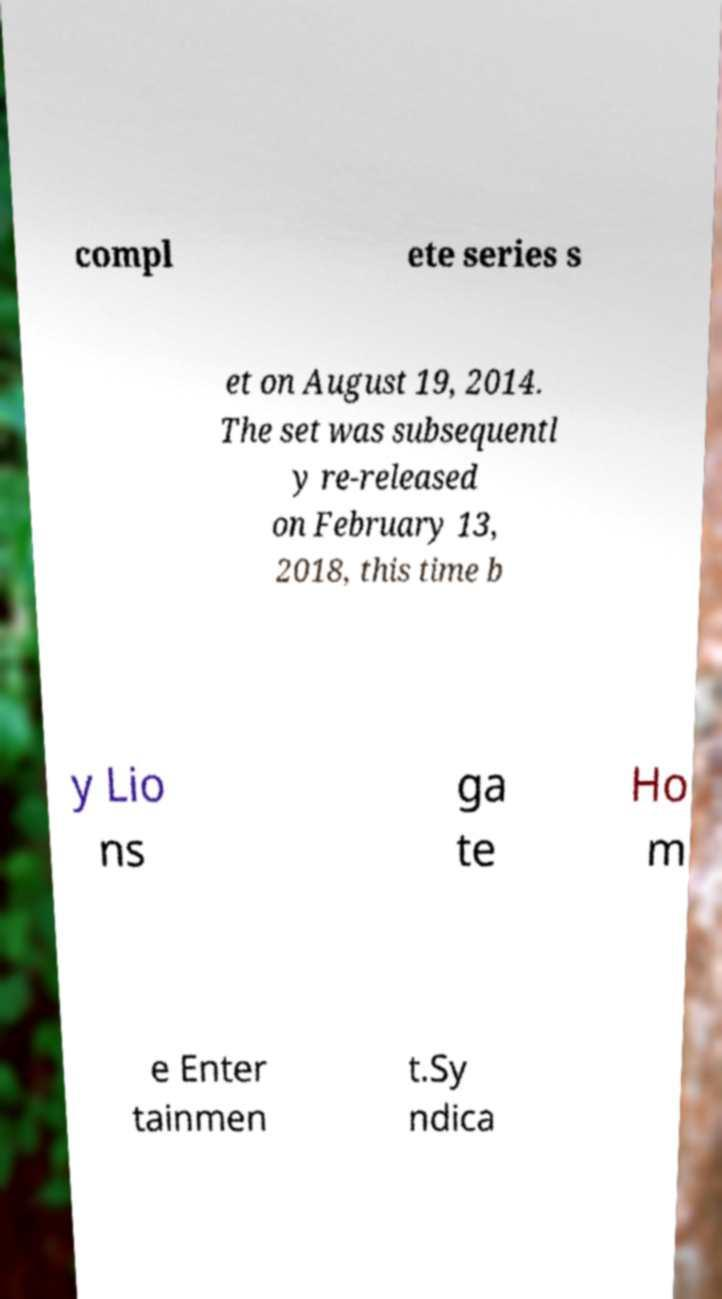What messages or text are displayed in this image? I need them in a readable, typed format. compl ete series s et on August 19, 2014. The set was subsequentl y re-released on February 13, 2018, this time b y Lio ns ga te Ho m e Enter tainmen t.Sy ndica 